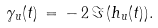Convert formula to latex. <formula><loc_0><loc_0><loc_500><loc_500>\gamma _ { u } ( t ) \, = \, - \, 2 \, \Im \, ( h _ { u } ( t ) ) .</formula> 